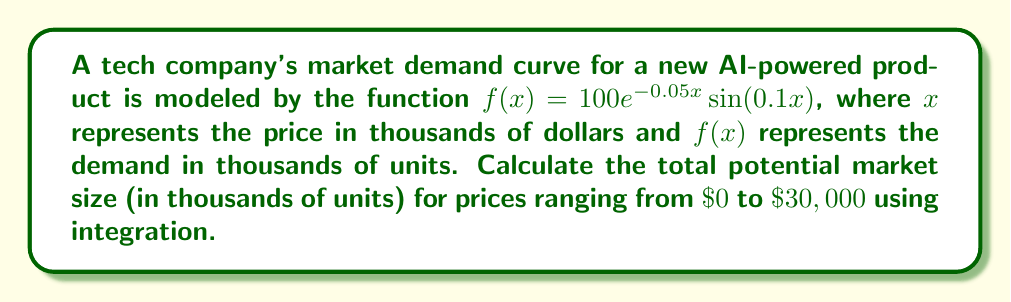What is the answer to this math problem? To solve this problem, we need to integrate the given function over the specified range. Here's the step-by-step process:

1. Set up the definite integral:
   $$\int_0^{30} 100e^{-0.05x}\sin(0.1x) dx$$

2. This integral cannot be solved using elementary antiderivatives. We need to use numerical integration methods. For this example, we'll use Simpson's Rule with 100 subintervals.

3. Simpson's Rule formula:
   $$\int_a^b f(x)dx \approx \frac{h}{3}[f(x_0) + 4f(x_1) + 2f(x_2) + 4f(x_3) + ... + 2f(x_{n-2}) + 4f(x_{n-1}) + f(x_n)]$$
   where $h = \frac{b-a}{n}$, $n$ is the number of subintervals (even), and $x_i = a + ih$

4. In our case:
   $a = 0$, $b = 30$, $n = 100$
   $h = \frac{30-0}{100} = 0.3$

5. Calculate the function values at each point:
   $x_0 = 0$, $f(x_0) = 0$
   $x_1 = 0.3$, $f(x_1) = 29.55$
   $x_2 = 0.6$, $f(x_2) = 56.84$
   ...
   $x_{99} = 29.7$, $f(x_{99}) = -0.45$
   $x_{100} = 30$, $f(x_{100}) = -0.74$

6. Apply Simpson's Rule:
   $$\text{Area} \approx \frac{0.3}{3}[0 + 4(29.55) + 2(56.84) + ... + 4(-0.45) + (-0.74)]$$

7. Compute the sum and multiply by $\frac{h}{3}$:
   $$\text{Area} \approx 263.76$$
Answer: 263.76 thousand units 